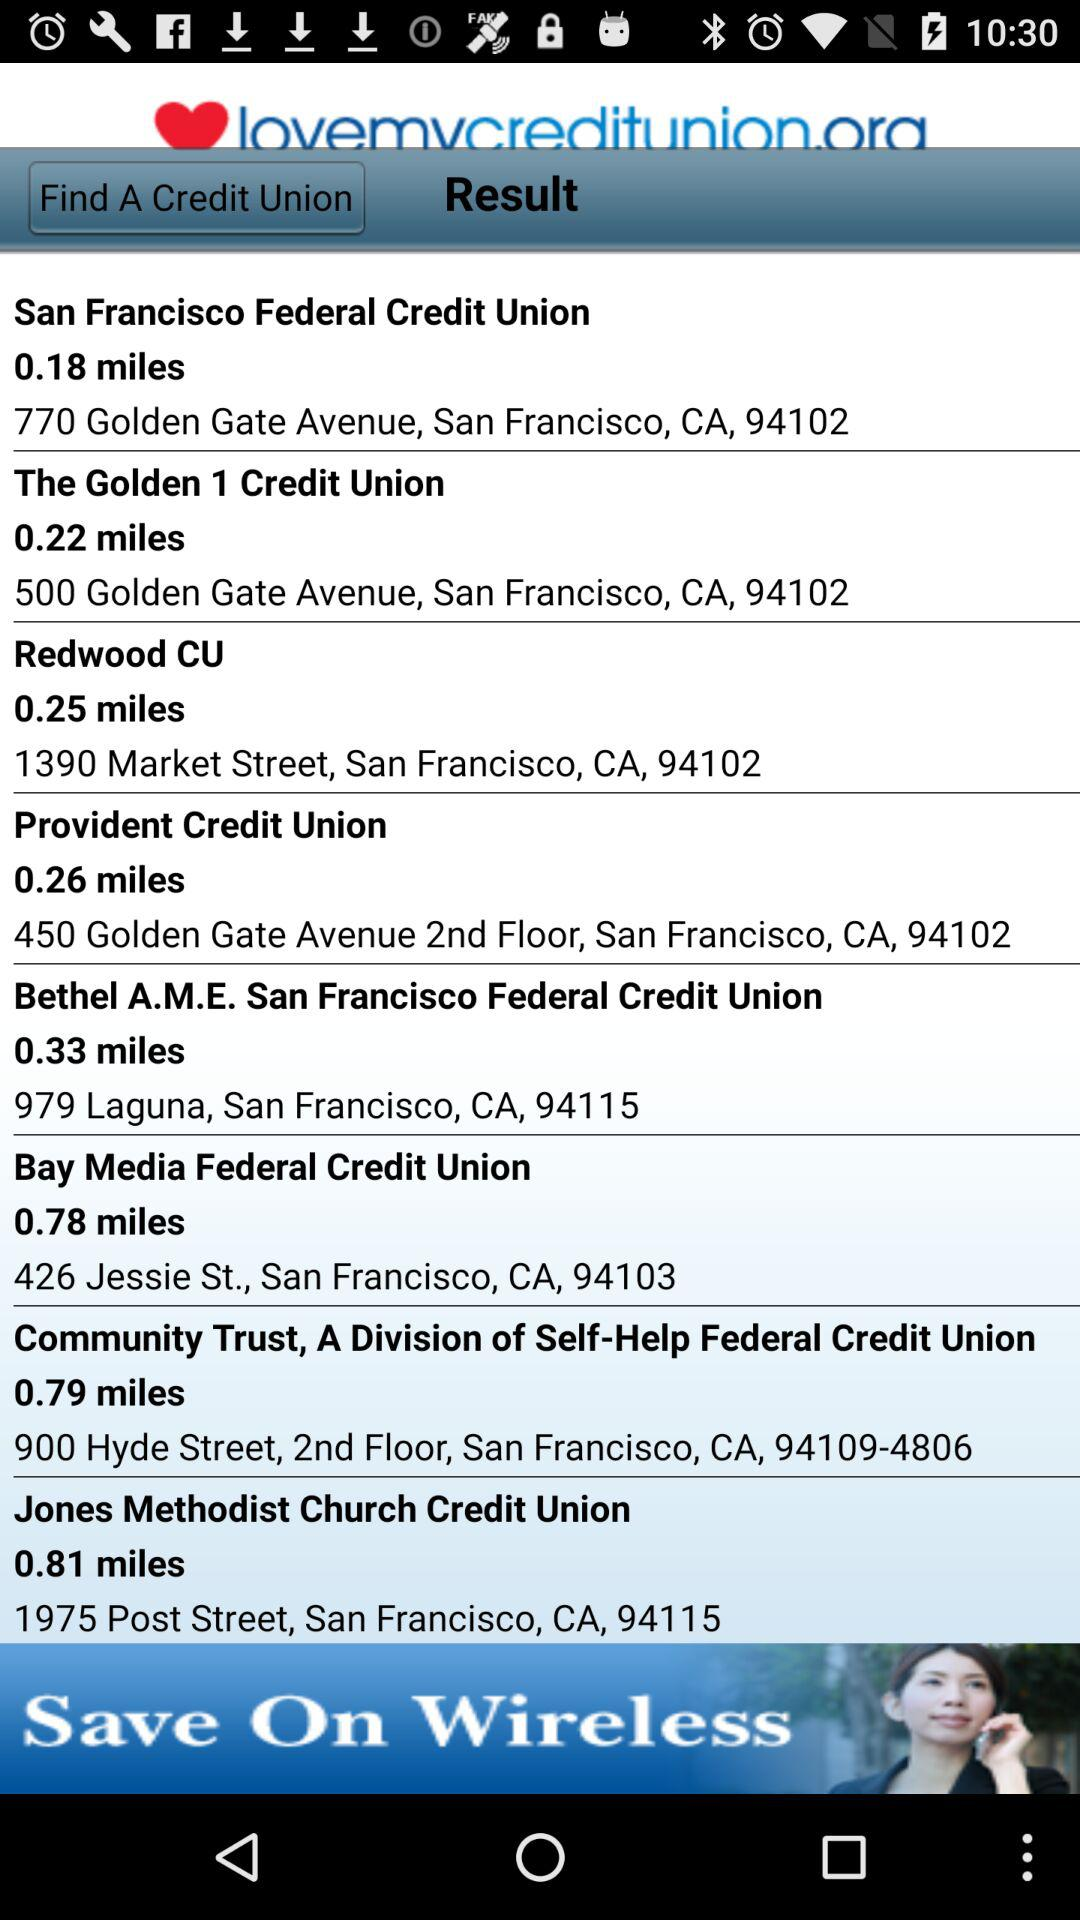What is the address of the "San Francisco Federal Credit Union"? The address of the "San Francisco Federal Credit Union" is 770 Golden Gate Avenue, San Francisco, CA, 94102. 